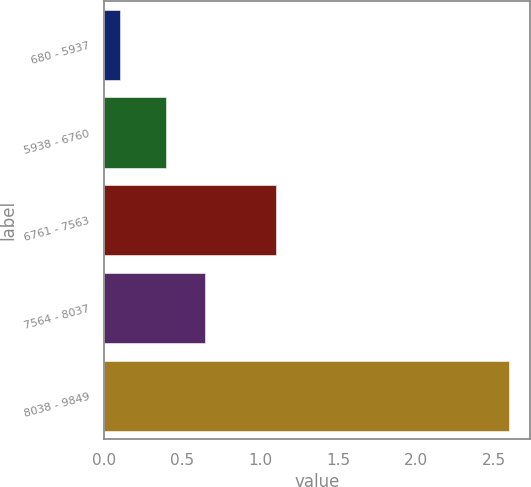<chart> <loc_0><loc_0><loc_500><loc_500><bar_chart><fcel>680 - 5937<fcel>5938 - 6760<fcel>6761 - 7563<fcel>7564 - 8037<fcel>8038 - 9849<nl><fcel>0.1<fcel>0.4<fcel>1.1<fcel>0.65<fcel>2.6<nl></chart> 